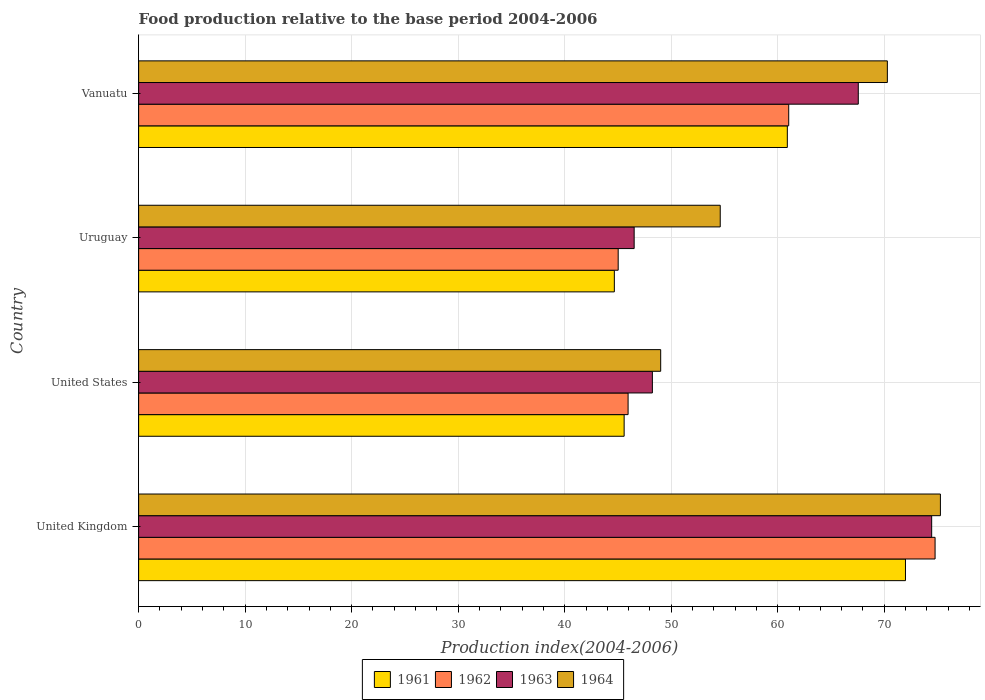Are the number of bars per tick equal to the number of legend labels?
Offer a very short reply. Yes. How many bars are there on the 3rd tick from the top?
Give a very brief answer. 4. How many bars are there on the 3rd tick from the bottom?
Offer a terse response. 4. In how many cases, is the number of bars for a given country not equal to the number of legend labels?
Give a very brief answer. 0. What is the food production index in 1961 in Uruguay?
Your answer should be very brief. 44.66. Across all countries, what is the maximum food production index in 1963?
Your response must be concise. 74.45. Across all countries, what is the minimum food production index in 1964?
Offer a very short reply. 49.01. What is the total food production index in 1961 in the graph?
Your response must be concise. 223.13. What is the difference between the food production index in 1964 in Uruguay and that in Vanuatu?
Your answer should be very brief. -15.69. What is the difference between the food production index in 1964 in Vanuatu and the food production index in 1963 in United Kingdom?
Offer a terse response. -4.16. What is the average food production index in 1964 per country?
Provide a short and direct response. 62.29. What is the difference between the food production index in 1962 and food production index in 1964 in United States?
Your answer should be compact. -3.06. What is the ratio of the food production index in 1963 in United Kingdom to that in Vanuatu?
Your answer should be very brief. 1.1. What is the difference between the highest and the second highest food production index in 1963?
Your response must be concise. 6.89. What is the difference between the highest and the lowest food production index in 1961?
Your response must be concise. 27.33. In how many countries, is the food production index in 1962 greater than the average food production index in 1962 taken over all countries?
Your answer should be very brief. 2. Is the sum of the food production index in 1963 in United States and Vanuatu greater than the maximum food production index in 1964 across all countries?
Your answer should be very brief. Yes. What does the 1st bar from the top in United Kingdom represents?
Provide a short and direct response. 1964. What does the 4th bar from the bottom in United States represents?
Offer a very short reply. 1964. How many bars are there?
Ensure brevity in your answer.  16. Are all the bars in the graph horizontal?
Provide a succinct answer. Yes. What is the difference between two consecutive major ticks on the X-axis?
Keep it short and to the point. 10. Does the graph contain any zero values?
Your response must be concise. No. What is the title of the graph?
Make the answer very short. Food production relative to the base period 2004-2006. Does "2012" appear as one of the legend labels in the graph?
Your answer should be very brief. No. What is the label or title of the X-axis?
Your answer should be very brief. Production index(2004-2006). What is the label or title of the Y-axis?
Provide a succinct answer. Country. What is the Production index(2004-2006) of 1961 in United Kingdom?
Your answer should be very brief. 71.99. What is the Production index(2004-2006) in 1962 in United Kingdom?
Provide a succinct answer. 74.77. What is the Production index(2004-2006) of 1963 in United Kingdom?
Keep it short and to the point. 74.45. What is the Production index(2004-2006) in 1964 in United Kingdom?
Keep it short and to the point. 75.27. What is the Production index(2004-2006) in 1961 in United States?
Provide a short and direct response. 45.58. What is the Production index(2004-2006) in 1962 in United States?
Provide a succinct answer. 45.95. What is the Production index(2004-2006) in 1963 in United States?
Ensure brevity in your answer.  48.23. What is the Production index(2004-2006) in 1964 in United States?
Give a very brief answer. 49.01. What is the Production index(2004-2006) of 1961 in Uruguay?
Ensure brevity in your answer.  44.66. What is the Production index(2004-2006) of 1962 in Uruguay?
Your response must be concise. 45.02. What is the Production index(2004-2006) in 1963 in Uruguay?
Provide a short and direct response. 46.52. What is the Production index(2004-2006) in 1964 in Uruguay?
Keep it short and to the point. 54.6. What is the Production index(2004-2006) in 1961 in Vanuatu?
Offer a very short reply. 60.9. What is the Production index(2004-2006) in 1962 in Vanuatu?
Your response must be concise. 61.03. What is the Production index(2004-2006) of 1963 in Vanuatu?
Provide a succinct answer. 67.56. What is the Production index(2004-2006) in 1964 in Vanuatu?
Offer a very short reply. 70.29. Across all countries, what is the maximum Production index(2004-2006) of 1961?
Keep it short and to the point. 71.99. Across all countries, what is the maximum Production index(2004-2006) of 1962?
Offer a very short reply. 74.77. Across all countries, what is the maximum Production index(2004-2006) of 1963?
Ensure brevity in your answer.  74.45. Across all countries, what is the maximum Production index(2004-2006) in 1964?
Make the answer very short. 75.27. Across all countries, what is the minimum Production index(2004-2006) in 1961?
Offer a terse response. 44.66. Across all countries, what is the minimum Production index(2004-2006) in 1962?
Your answer should be very brief. 45.02. Across all countries, what is the minimum Production index(2004-2006) in 1963?
Provide a succinct answer. 46.52. Across all countries, what is the minimum Production index(2004-2006) of 1964?
Offer a terse response. 49.01. What is the total Production index(2004-2006) in 1961 in the graph?
Provide a short and direct response. 223.13. What is the total Production index(2004-2006) in 1962 in the graph?
Provide a succinct answer. 226.77. What is the total Production index(2004-2006) in 1963 in the graph?
Make the answer very short. 236.76. What is the total Production index(2004-2006) in 1964 in the graph?
Offer a terse response. 249.17. What is the difference between the Production index(2004-2006) in 1961 in United Kingdom and that in United States?
Provide a short and direct response. 26.41. What is the difference between the Production index(2004-2006) in 1962 in United Kingdom and that in United States?
Offer a very short reply. 28.82. What is the difference between the Production index(2004-2006) of 1963 in United Kingdom and that in United States?
Keep it short and to the point. 26.22. What is the difference between the Production index(2004-2006) of 1964 in United Kingdom and that in United States?
Keep it short and to the point. 26.26. What is the difference between the Production index(2004-2006) in 1961 in United Kingdom and that in Uruguay?
Give a very brief answer. 27.33. What is the difference between the Production index(2004-2006) of 1962 in United Kingdom and that in Uruguay?
Give a very brief answer. 29.75. What is the difference between the Production index(2004-2006) in 1963 in United Kingdom and that in Uruguay?
Provide a short and direct response. 27.93. What is the difference between the Production index(2004-2006) in 1964 in United Kingdom and that in Uruguay?
Keep it short and to the point. 20.67. What is the difference between the Production index(2004-2006) in 1961 in United Kingdom and that in Vanuatu?
Offer a terse response. 11.09. What is the difference between the Production index(2004-2006) of 1962 in United Kingdom and that in Vanuatu?
Give a very brief answer. 13.74. What is the difference between the Production index(2004-2006) in 1963 in United Kingdom and that in Vanuatu?
Ensure brevity in your answer.  6.89. What is the difference between the Production index(2004-2006) in 1964 in United Kingdom and that in Vanuatu?
Provide a succinct answer. 4.98. What is the difference between the Production index(2004-2006) in 1962 in United States and that in Uruguay?
Your response must be concise. 0.93. What is the difference between the Production index(2004-2006) of 1963 in United States and that in Uruguay?
Your answer should be compact. 1.71. What is the difference between the Production index(2004-2006) in 1964 in United States and that in Uruguay?
Offer a very short reply. -5.59. What is the difference between the Production index(2004-2006) in 1961 in United States and that in Vanuatu?
Keep it short and to the point. -15.32. What is the difference between the Production index(2004-2006) of 1962 in United States and that in Vanuatu?
Give a very brief answer. -15.08. What is the difference between the Production index(2004-2006) in 1963 in United States and that in Vanuatu?
Provide a short and direct response. -19.33. What is the difference between the Production index(2004-2006) of 1964 in United States and that in Vanuatu?
Your response must be concise. -21.28. What is the difference between the Production index(2004-2006) in 1961 in Uruguay and that in Vanuatu?
Provide a short and direct response. -16.24. What is the difference between the Production index(2004-2006) in 1962 in Uruguay and that in Vanuatu?
Provide a short and direct response. -16.01. What is the difference between the Production index(2004-2006) of 1963 in Uruguay and that in Vanuatu?
Give a very brief answer. -21.04. What is the difference between the Production index(2004-2006) in 1964 in Uruguay and that in Vanuatu?
Make the answer very short. -15.69. What is the difference between the Production index(2004-2006) in 1961 in United Kingdom and the Production index(2004-2006) in 1962 in United States?
Offer a very short reply. 26.04. What is the difference between the Production index(2004-2006) of 1961 in United Kingdom and the Production index(2004-2006) of 1963 in United States?
Ensure brevity in your answer.  23.76. What is the difference between the Production index(2004-2006) of 1961 in United Kingdom and the Production index(2004-2006) of 1964 in United States?
Give a very brief answer. 22.98. What is the difference between the Production index(2004-2006) in 1962 in United Kingdom and the Production index(2004-2006) in 1963 in United States?
Ensure brevity in your answer.  26.54. What is the difference between the Production index(2004-2006) of 1962 in United Kingdom and the Production index(2004-2006) of 1964 in United States?
Your answer should be very brief. 25.76. What is the difference between the Production index(2004-2006) of 1963 in United Kingdom and the Production index(2004-2006) of 1964 in United States?
Provide a succinct answer. 25.44. What is the difference between the Production index(2004-2006) in 1961 in United Kingdom and the Production index(2004-2006) in 1962 in Uruguay?
Give a very brief answer. 26.97. What is the difference between the Production index(2004-2006) of 1961 in United Kingdom and the Production index(2004-2006) of 1963 in Uruguay?
Ensure brevity in your answer.  25.47. What is the difference between the Production index(2004-2006) in 1961 in United Kingdom and the Production index(2004-2006) in 1964 in Uruguay?
Ensure brevity in your answer.  17.39. What is the difference between the Production index(2004-2006) in 1962 in United Kingdom and the Production index(2004-2006) in 1963 in Uruguay?
Offer a very short reply. 28.25. What is the difference between the Production index(2004-2006) of 1962 in United Kingdom and the Production index(2004-2006) of 1964 in Uruguay?
Your response must be concise. 20.17. What is the difference between the Production index(2004-2006) in 1963 in United Kingdom and the Production index(2004-2006) in 1964 in Uruguay?
Give a very brief answer. 19.85. What is the difference between the Production index(2004-2006) in 1961 in United Kingdom and the Production index(2004-2006) in 1962 in Vanuatu?
Give a very brief answer. 10.96. What is the difference between the Production index(2004-2006) of 1961 in United Kingdom and the Production index(2004-2006) of 1963 in Vanuatu?
Give a very brief answer. 4.43. What is the difference between the Production index(2004-2006) of 1962 in United Kingdom and the Production index(2004-2006) of 1963 in Vanuatu?
Keep it short and to the point. 7.21. What is the difference between the Production index(2004-2006) in 1962 in United Kingdom and the Production index(2004-2006) in 1964 in Vanuatu?
Provide a short and direct response. 4.48. What is the difference between the Production index(2004-2006) in 1963 in United Kingdom and the Production index(2004-2006) in 1964 in Vanuatu?
Offer a terse response. 4.16. What is the difference between the Production index(2004-2006) in 1961 in United States and the Production index(2004-2006) in 1962 in Uruguay?
Make the answer very short. 0.56. What is the difference between the Production index(2004-2006) in 1961 in United States and the Production index(2004-2006) in 1963 in Uruguay?
Provide a short and direct response. -0.94. What is the difference between the Production index(2004-2006) of 1961 in United States and the Production index(2004-2006) of 1964 in Uruguay?
Provide a succinct answer. -9.02. What is the difference between the Production index(2004-2006) of 1962 in United States and the Production index(2004-2006) of 1963 in Uruguay?
Offer a terse response. -0.57. What is the difference between the Production index(2004-2006) of 1962 in United States and the Production index(2004-2006) of 1964 in Uruguay?
Your response must be concise. -8.65. What is the difference between the Production index(2004-2006) of 1963 in United States and the Production index(2004-2006) of 1964 in Uruguay?
Your response must be concise. -6.37. What is the difference between the Production index(2004-2006) in 1961 in United States and the Production index(2004-2006) in 1962 in Vanuatu?
Ensure brevity in your answer.  -15.45. What is the difference between the Production index(2004-2006) in 1961 in United States and the Production index(2004-2006) in 1963 in Vanuatu?
Your answer should be compact. -21.98. What is the difference between the Production index(2004-2006) in 1961 in United States and the Production index(2004-2006) in 1964 in Vanuatu?
Ensure brevity in your answer.  -24.71. What is the difference between the Production index(2004-2006) of 1962 in United States and the Production index(2004-2006) of 1963 in Vanuatu?
Provide a short and direct response. -21.61. What is the difference between the Production index(2004-2006) of 1962 in United States and the Production index(2004-2006) of 1964 in Vanuatu?
Offer a very short reply. -24.34. What is the difference between the Production index(2004-2006) of 1963 in United States and the Production index(2004-2006) of 1964 in Vanuatu?
Your answer should be compact. -22.06. What is the difference between the Production index(2004-2006) of 1961 in Uruguay and the Production index(2004-2006) of 1962 in Vanuatu?
Keep it short and to the point. -16.37. What is the difference between the Production index(2004-2006) of 1961 in Uruguay and the Production index(2004-2006) of 1963 in Vanuatu?
Ensure brevity in your answer.  -22.9. What is the difference between the Production index(2004-2006) in 1961 in Uruguay and the Production index(2004-2006) in 1964 in Vanuatu?
Make the answer very short. -25.63. What is the difference between the Production index(2004-2006) in 1962 in Uruguay and the Production index(2004-2006) in 1963 in Vanuatu?
Your response must be concise. -22.54. What is the difference between the Production index(2004-2006) in 1962 in Uruguay and the Production index(2004-2006) in 1964 in Vanuatu?
Keep it short and to the point. -25.27. What is the difference between the Production index(2004-2006) in 1963 in Uruguay and the Production index(2004-2006) in 1964 in Vanuatu?
Keep it short and to the point. -23.77. What is the average Production index(2004-2006) in 1961 per country?
Provide a short and direct response. 55.78. What is the average Production index(2004-2006) of 1962 per country?
Offer a terse response. 56.69. What is the average Production index(2004-2006) of 1963 per country?
Give a very brief answer. 59.19. What is the average Production index(2004-2006) in 1964 per country?
Make the answer very short. 62.29. What is the difference between the Production index(2004-2006) of 1961 and Production index(2004-2006) of 1962 in United Kingdom?
Give a very brief answer. -2.78. What is the difference between the Production index(2004-2006) of 1961 and Production index(2004-2006) of 1963 in United Kingdom?
Offer a very short reply. -2.46. What is the difference between the Production index(2004-2006) in 1961 and Production index(2004-2006) in 1964 in United Kingdom?
Your answer should be very brief. -3.28. What is the difference between the Production index(2004-2006) of 1962 and Production index(2004-2006) of 1963 in United Kingdom?
Your answer should be very brief. 0.32. What is the difference between the Production index(2004-2006) in 1962 and Production index(2004-2006) in 1964 in United Kingdom?
Keep it short and to the point. -0.5. What is the difference between the Production index(2004-2006) of 1963 and Production index(2004-2006) of 1964 in United Kingdom?
Offer a terse response. -0.82. What is the difference between the Production index(2004-2006) in 1961 and Production index(2004-2006) in 1962 in United States?
Give a very brief answer. -0.37. What is the difference between the Production index(2004-2006) in 1961 and Production index(2004-2006) in 1963 in United States?
Your answer should be compact. -2.65. What is the difference between the Production index(2004-2006) in 1961 and Production index(2004-2006) in 1964 in United States?
Keep it short and to the point. -3.43. What is the difference between the Production index(2004-2006) in 1962 and Production index(2004-2006) in 1963 in United States?
Make the answer very short. -2.28. What is the difference between the Production index(2004-2006) of 1962 and Production index(2004-2006) of 1964 in United States?
Your answer should be very brief. -3.06. What is the difference between the Production index(2004-2006) of 1963 and Production index(2004-2006) of 1964 in United States?
Provide a short and direct response. -0.78. What is the difference between the Production index(2004-2006) of 1961 and Production index(2004-2006) of 1962 in Uruguay?
Your answer should be compact. -0.36. What is the difference between the Production index(2004-2006) of 1961 and Production index(2004-2006) of 1963 in Uruguay?
Provide a succinct answer. -1.86. What is the difference between the Production index(2004-2006) of 1961 and Production index(2004-2006) of 1964 in Uruguay?
Give a very brief answer. -9.94. What is the difference between the Production index(2004-2006) in 1962 and Production index(2004-2006) in 1964 in Uruguay?
Make the answer very short. -9.58. What is the difference between the Production index(2004-2006) in 1963 and Production index(2004-2006) in 1964 in Uruguay?
Provide a short and direct response. -8.08. What is the difference between the Production index(2004-2006) of 1961 and Production index(2004-2006) of 1962 in Vanuatu?
Your answer should be very brief. -0.13. What is the difference between the Production index(2004-2006) of 1961 and Production index(2004-2006) of 1963 in Vanuatu?
Your response must be concise. -6.66. What is the difference between the Production index(2004-2006) in 1961 and Production index(2004-2006) in 1964 in Vanuatu?
Make the answer very short. -9.39. What is the difference between the Production index(2004-2006) in 1962 and Production index(2004-2006) in 1963 in Vanuatu?
Provide a short and direct response. -6.53. What is the difference between the Production index(2004-2006) in 1962 and Production index(2004-2006) in 1964 in Vanuatu?
Provide a succinct answer. -9.26. What is the difference between the Production index(2004-2006) of 1963 and Production index(2004-2006) of 1964 in Vanuatu?
Provide a short and direct response. -2.73. What is the ratio of the Production index(2004-2006) of 1961 in United Kingdom to that in United States?
Make the answer very short. 1.58. What is the ratio of the Production index(2004-2006) of 1962 in United Kingdom to that in United States?
Offer a terse response. 1.63. What is the ratio of the Production index(2004-2006) of 1963 in United Kingdom to that in United States?
Your answer should be compact. 1.54. What is the ratio of the Production index(2004-2006) in 1964 in United Kingdom to that in United States?
Keep it short and to the point. 1.54. What is the ratio of the Production index(2004-2006) in 1961 in United Kingdom to that in Uruguay?
Keep it short and to the point. 1.61. What is the ratio of the Production index(2004-2006) of 1962 in United Kingdom to that in Uruguay?
Keep it short and to the point. 1.66. What is the ratio of the Production index(2004-2006) of 1963 in United Kingdom to that in Uruguay?
Offer a terse response. 1.6. What is the ratio of the Production index(2004-2006) of 1964 in United Kingdom to that in Uruguay?
Your answer should be very brief. 1.38. What is the ratio of the Production index(2004-2006) of 1961 in United Kingdom to that in Vanuatu?
Your answer should be very brief. 1.18. What is the ratio of the Production index(2004-2006) in 1962 in United Kingdom to that in Vanuatu?
Give a very brief answer. 1.23. What is the ratio of the Production index(2004-2006) of 1963 in United Kingdom to that in Vanuatu?
Provide a succinct answer. 1.1. What is the ratio of the Production index(2004-2006) of 1964 in United Kingdom to that in Vanuatu?
Make the answer very short. 1.07. What is the ratio of the Production index(2004-2006) of 1961 in United States to that in Uruguay?
Your answer should be very brief. 1.02. What is the ratio of the Production index(2004-2006) in 1962 in United States to that in Uruguay?
Your answer should be very brief. 1.02. What is the ratio of the Production index(2004-2006) of 1963 in United States to that in Uruguay?
Your answer should be very brief. 1.04. What is the ratio of the Production index(2004-2006) of 1964 in United States to that in Uruguay?
Offer a terse response. 0.9. What is the ratio of the Production index(2004-2006) of 1961 in United States to that in Vanuatu?
Provide a short and direct response. 0.75. What is the ratio of the Production index(2004-2006) in 1962 in United States to that in Vanuatu?
Provide a succinct answer. 0.75. What is the ratio of the Production index(2004-2006) of 1963 in United States to that in Vanuatu?
Provide a succinct answer. 0.71. What is the ratio of the Production index(2004-2006) in 1964 in United States to that in Vanuatu?
Provide a succinct answer. 0.7. What is the ratio of the Production index(2004-2006) in 1961 in Uruguay to that in Vanuatu?
Offer a terse response. 0.73. What is the ratio of the Production index(2004-2006) of 1962 in Uruguay to that in Vanuatu?
Ensure brevity in your answer.  0.74. What is the ratio of the Production index(2004-2006) in 1963 in Uruguay to that in Vanuatu?
Offer a terse response. 0.69. What is the ratio of the Production index(2004-2006) in 1964 in Uruguay to that in Vanuatu?
Your response must be concise. 0.78. What is the difference between the highest and the second highest Production index(2004-2006) in 1961?
Your response must be concise. 11.09. What is the difference between the highest and the second highest Production index(2004-2006) in 1962?
Your response must be concise. 13.74. What is the difference between the highest and the second highest Production index(2004-2006) in 1963?
Provide a short and direct response. 6.89. What is the difference between the highest and the second highest Production index(2004-2006) in 1964?
Offer a terse response. 4.98. What is the difference between the highest and the lowest Production index(2004-2006) of 1961?
Provide a short and direct response. 27.33. What is the difference between the highest and the lowest Production index(2004-2006) in 1962?
Give a very brief answer. 29.75. What is the difference between the highest and the lowest Production index(2004-2006) of 1963?
Make the answer very short. 27.93. What is the difference between the highest and the lowest Production index(2004-2006) in 1964?
Offer a very short reply. 26.26. 